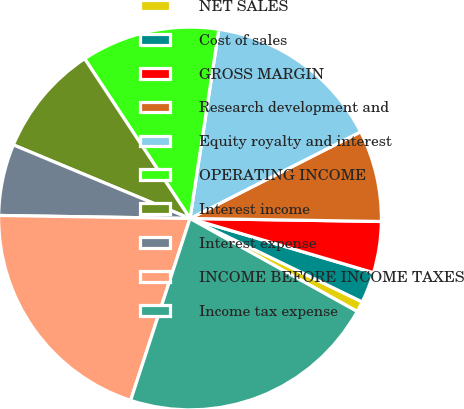Convert chart. <chart><loc_0><loc_0><loc_500><loc_500><pie_chart><fcel>NET SALES<fcel>Cost of sales<fcel>GROSS MARGIN<fcel>Research development and<fcel>Equity royalty and interest<fcel>OPERATING INCOME<fcel>Interest income<fcel>Interest expense<fcel>INCOME BEFORE INCOME TAXES<fcel>Income tax expense<nl><fcel>0.9%<fcel>2.61%<fcel>4.32%<fcel>7.73%<fcel>15.11%<fcel>11.69%<fcel>9.44%<fcel>6.03%<fcel>20.23%<fcel>21.94%<nl></chart> 